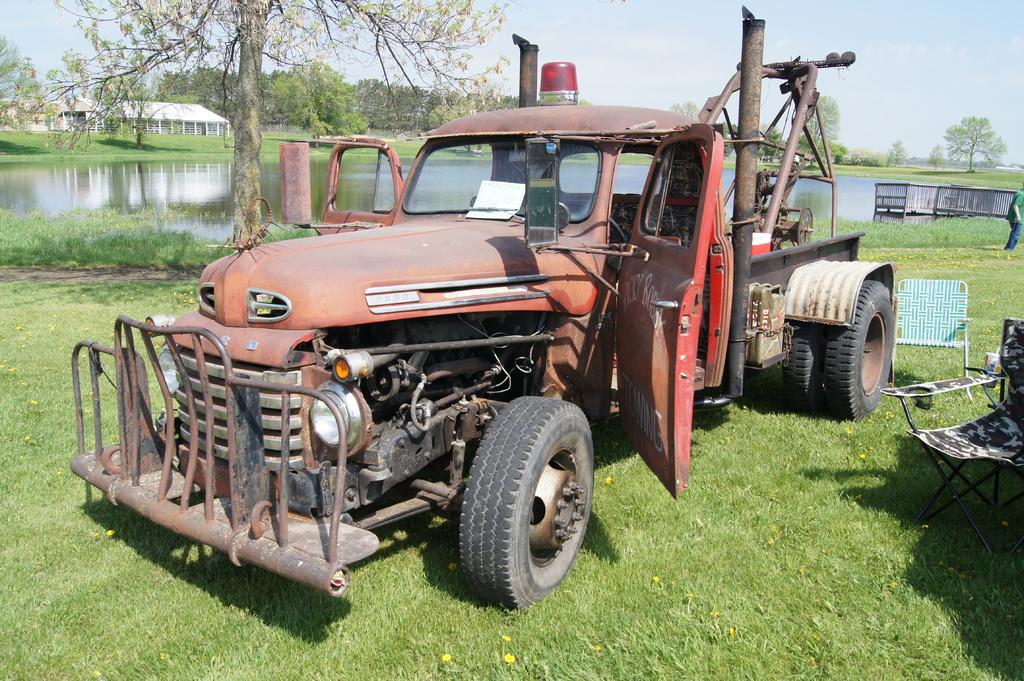What is located on the grass in the image? There is a vehicle on the grass in the image. What type of furniture can be seen in the image? There are chairs in the image. What type of barrier is present in the image? There is a fence in the image. What natural element is visible in the image? There is water visible in the image. What type of vegetation is present in the image? There are trees in the image. What type of structures can be seen in the image? There are houses in the image. Who or what is present in the image? There is a person in the image. What is visible in the background of the image? The sky is visible in the background of the image. What nation is represented by the flag in the image? There is no flag present in the image, so it is not possible to determine which nation might be represented. How many people are walking in the image? There is no indication of anyone walking in the image; the person present is standing. 